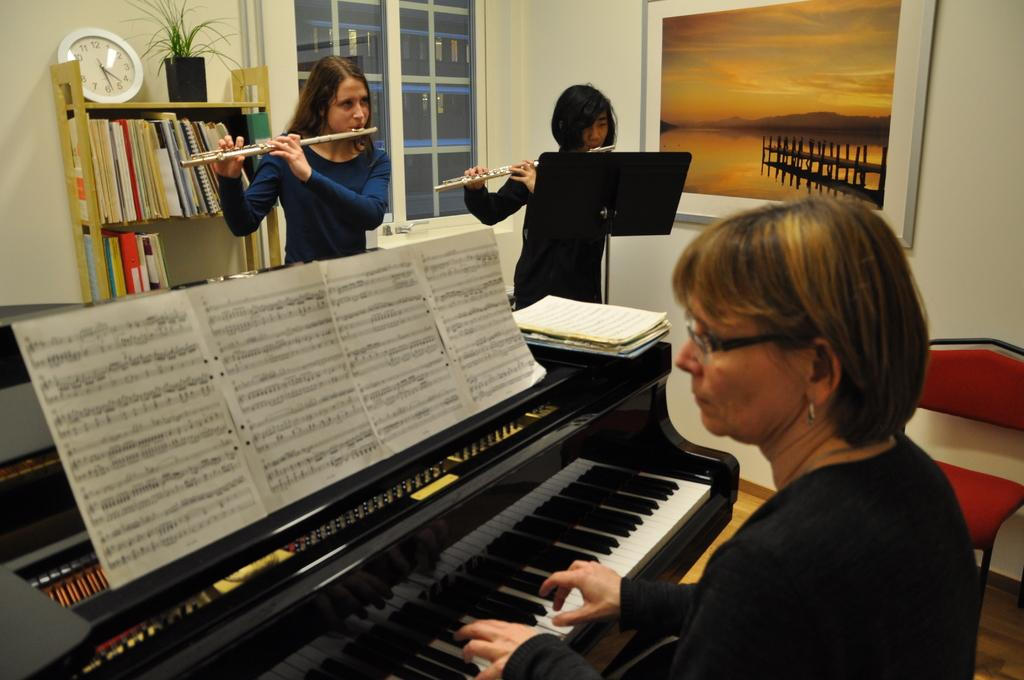Where was the image taken? The image was taken inside a room. Who is present in the image? There is a woman and two girls in the image. What is the woman doing in the image? The woman is playing a piano. What are the girls doing in the image? The girls are playing flutes. Can you see any dolls or cows in the image? No, there are no dolls or cows present in the image. 